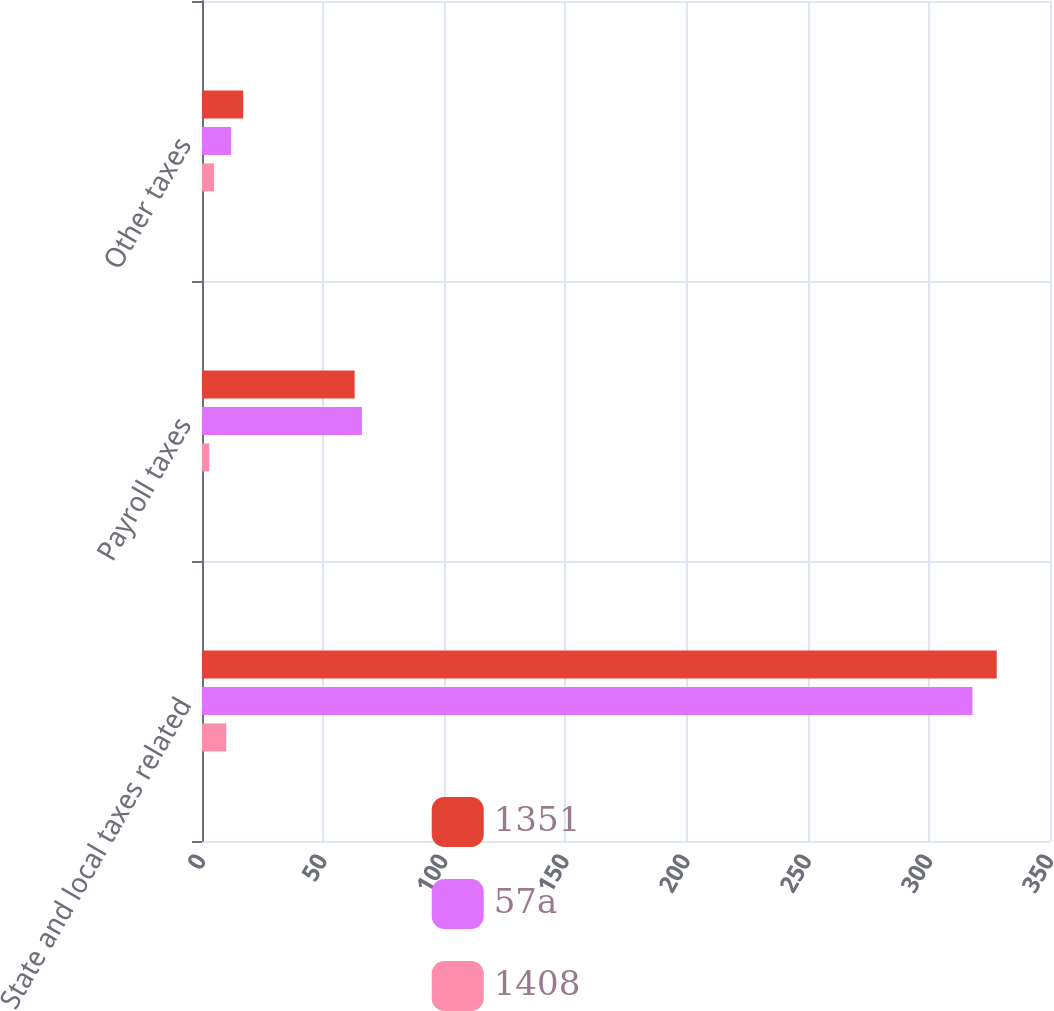Convert chart. <chart><loc_0><loc_0><loc_500><loc_500><stacked_bar_chart><ecel><fcel>State and local taxes related<fcel>Payroll taxes<fcel>Other taxes<nl><fcel>1351<fcel>328<fcel>63<fcel>17<nl><fcel>57a<fcel>318<fcel>66<fcel>12<nl><fcel>1408<fcel>10<fcel>3<fcel>5<nl></chart> 